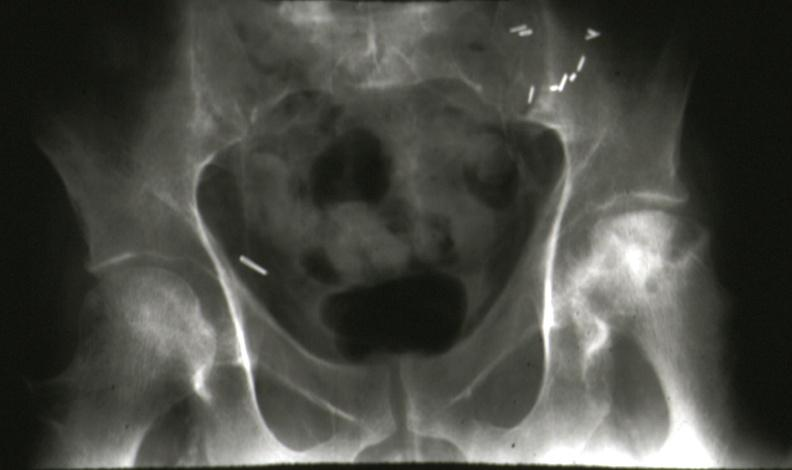what does this image show?
Answer the question using a single word or phrase. X-ray pelvis showing very nicely bilateral femoral head necrosis renal transplant case 